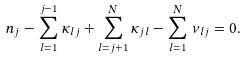Convert formula to latex. <formula><loc_0><loc_0><loc_500><loc_500>n _ { j } - \sum _ { l = 1 } ^ { j - 1 } \kappa _ { l j } + \sum _ { l = j + 1 } ^ { N } \kappa _ { j l } - \sum _ { l = 1 } ^ { N } \nu _ { l j } = 0 .</formula> 